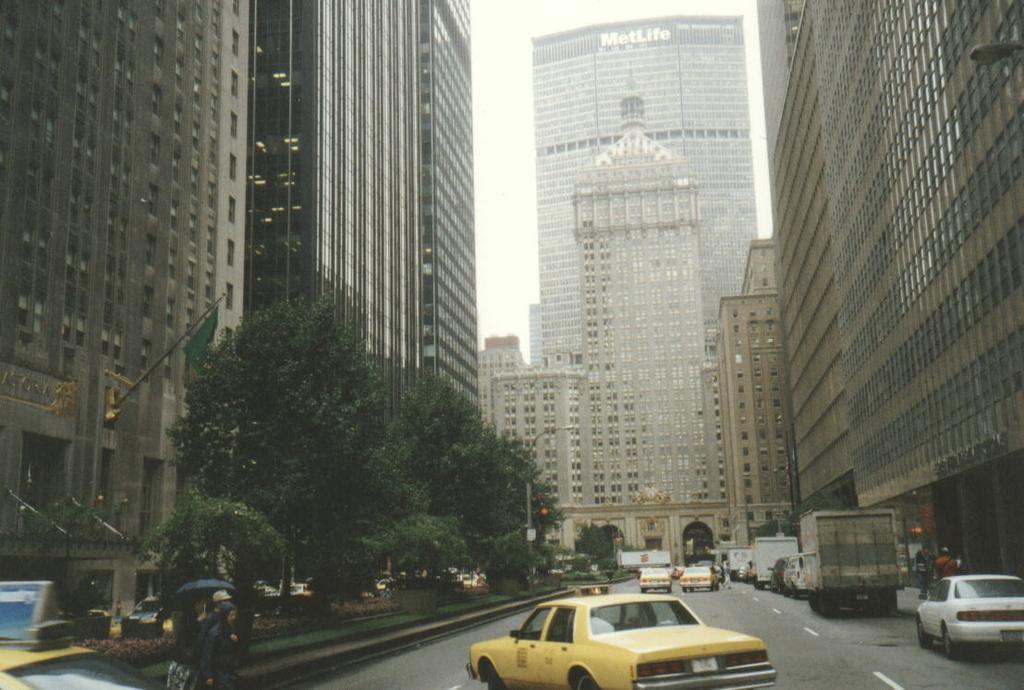<image>
Create a compact narrative representing the image presented. A high rise building with the words Met Life on top 